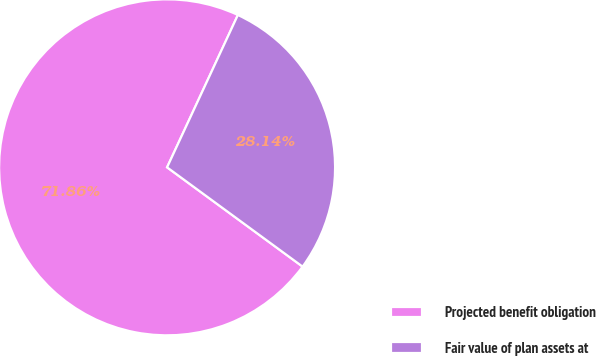Convert chart to OTSL. <chart><loc_0><loc_0><loc_500><loc_500><pie_chart><fcel>Projected benefit obligation<fcel>Fair value of plan assets at<nl><fcel>71.86%<fcel>28.14%<nl></chart> 